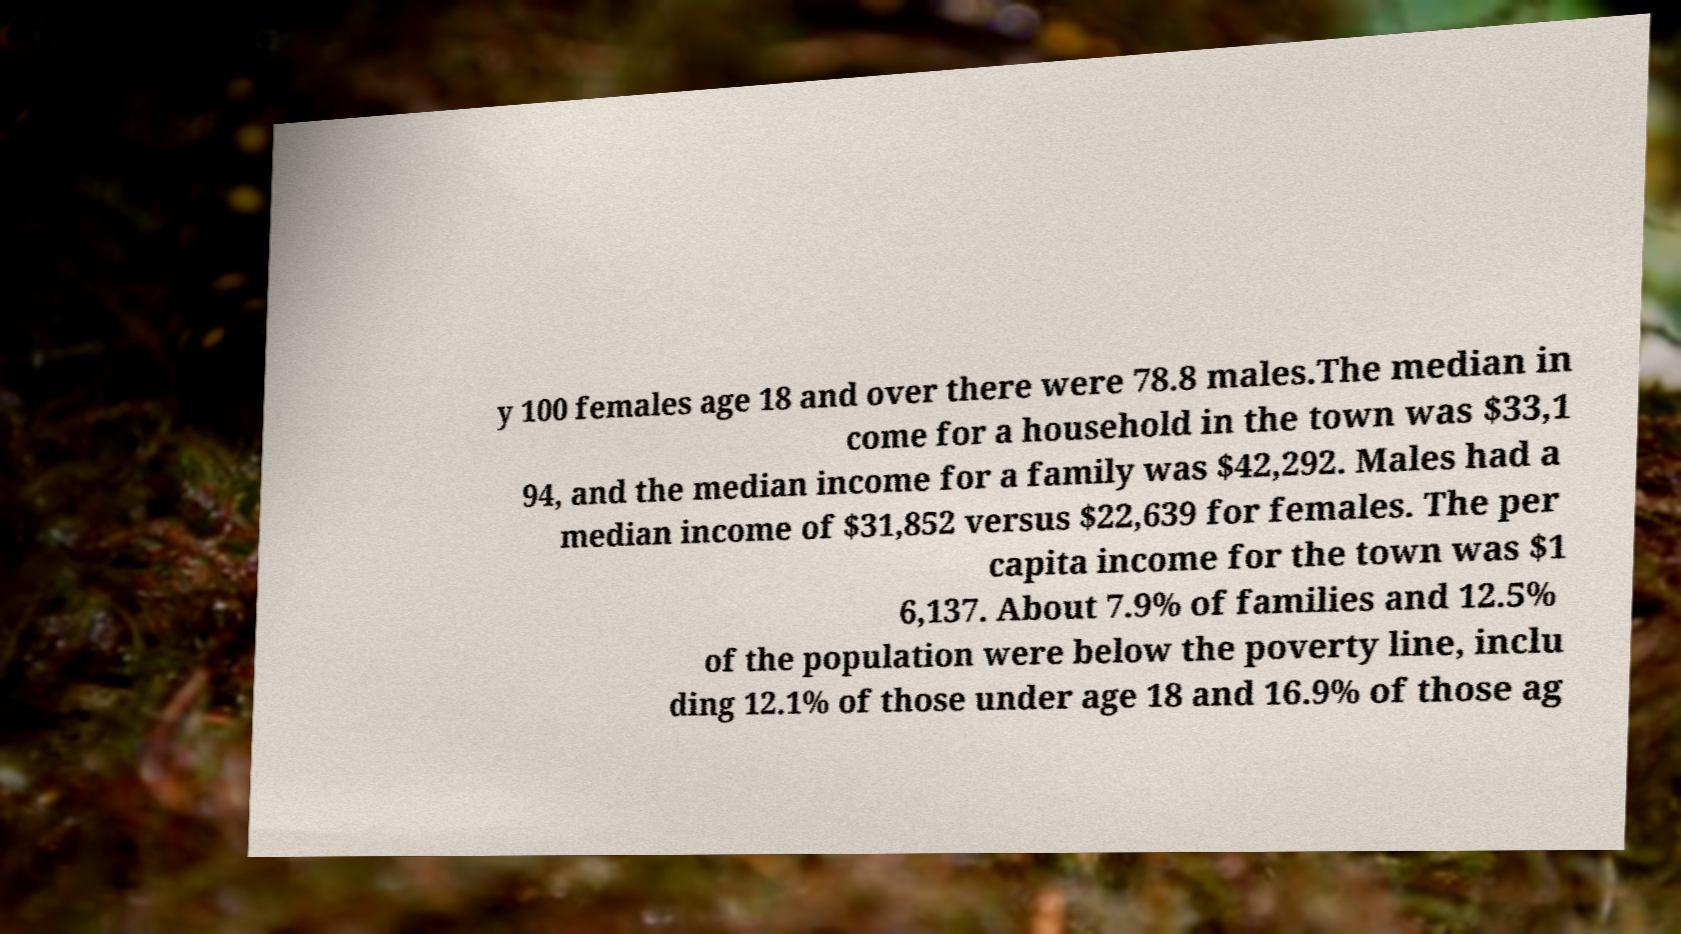What messages or text are displayed in this image? I need them in a readable, typed format. y 100 females age 18 and over there were 78.8 males.The median in come for a household in the town was $33,1 94, and the median income for a family was $42,292. Males had a median income of $31,852 versus $22,639 for females. The per capita income for the town was $1 6,137. About 7.9% of families and 12.5% of the population were below the poverty line, inclu ding 12.1% of those under age 18 and 16.9% of those ag 